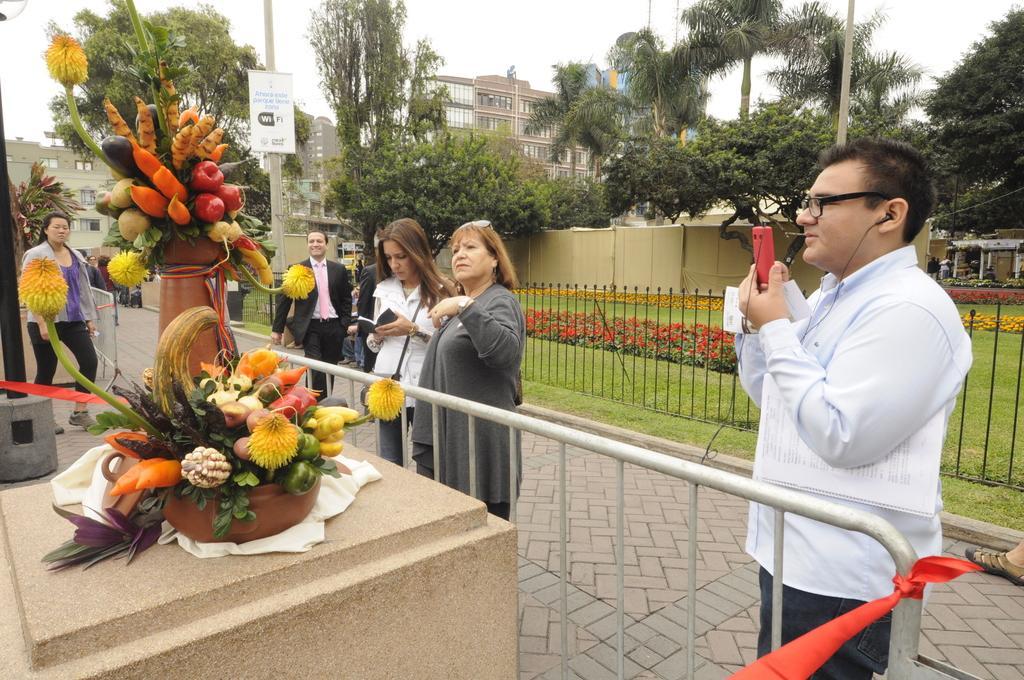Describe this image in one or two sentences. In this image in the center there are a group of people who are standing, and one person is holding a mobile and one person is holding a book. And on the left side there are some fruit carvings, and also we would see a tape around it. And there is a railing, grass, plants and walkway. In the background there are buildings, trees, poles and boards. At the top there is sky. 